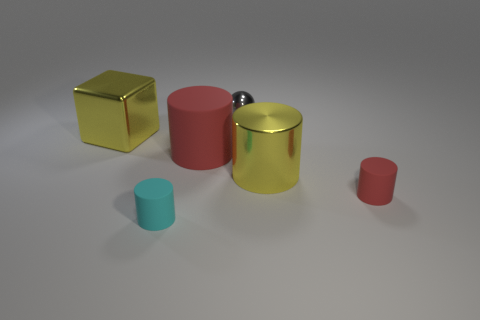What number of yellow metallic cylinders are the same size as the cyan rubber cylinder?
Ensure brevity in your answer.  0. What is the color of the small thing that is in front of the large block and right of the small cyan rubber cylinder?
Offer a terse response. Red. Is the number of yellow shiny cubes less than the number of small matte cylinders?
Make the answer very short. Yes. There is a large metallic cube; does it have the same color as the big cylinder on the right side of the large red matte thing?
Your answer should be very brief. Yes. Are there the same number of big yellow metallic blocks that are in front of the shiny cylinder and small cyan matte cylinders that are right of the gray metal thing?
Make the answer very short. Yes. What number of other big things have the same shape as the cyan thing?
Offer a terse response. 2. Are any yellow things visible?
Offer a terse response. Yes. Are the large red object and the red cylinder that is in front of the large metal cylinder made of the same material?
Your response must be concise. Yes. There is a red cylinder that is the same size as the sphere; what is its material?
Give a very brief answer. Rubber. Is there a big thing made of the same material as the tiny cyan cylinder?
Offer a terse response. Yes. 